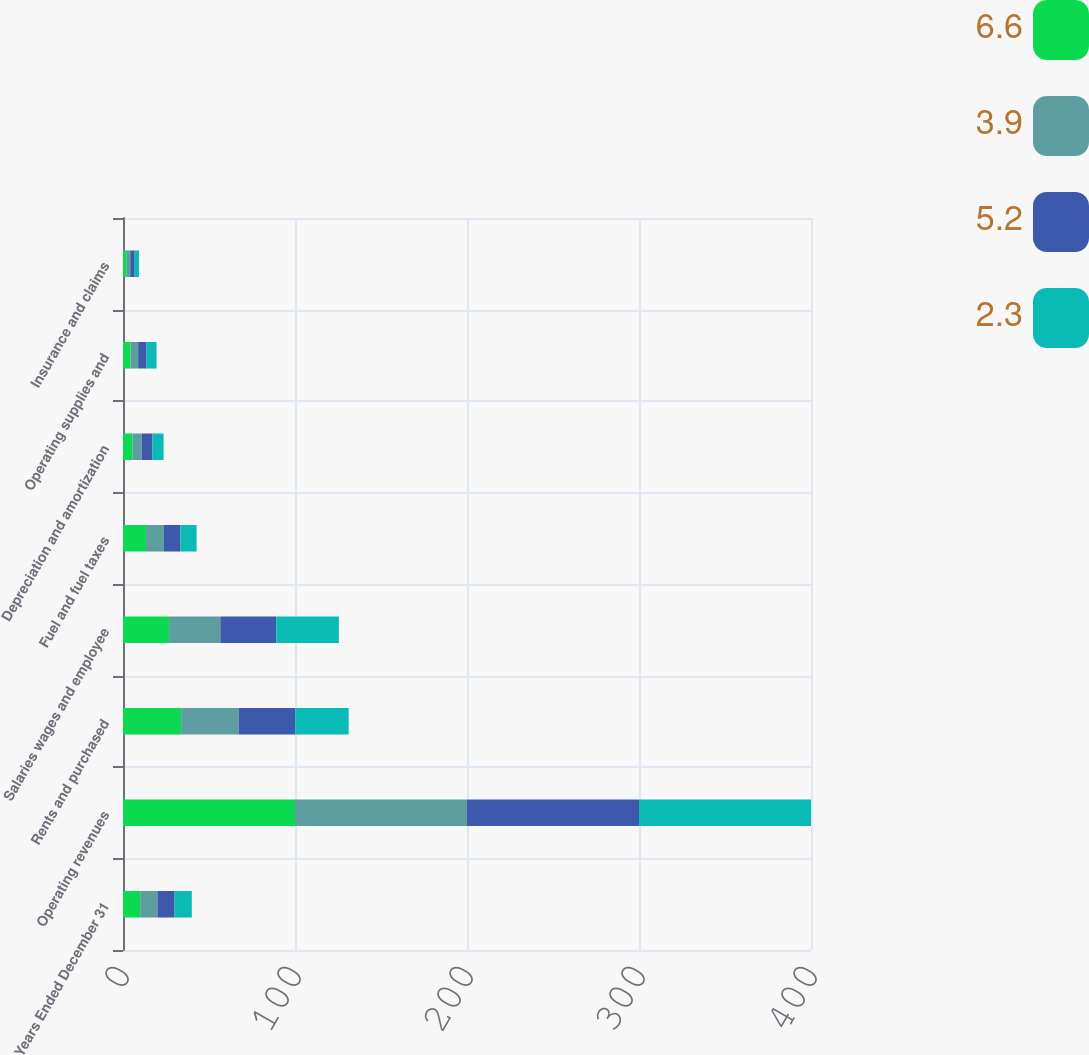Convert chart to OTSL. <chart><loc_0><loc_0><loc_500><loc_500><stacked_bar_chart><ecel><fcel>Years Ended December 31<fcel>Operating revenues<fcel>Rents and purchased<fcel>Salaries wages and employee<fcel>Fuel and fuel taxes<fcel>Depreciation and amortization<fcel>Operating supplies and<fcel>Insurance and claims<nl><fcel>6.6<fcel>10<fcel>100<fcel>33.8<fcel>26.8<fcel>13.4<fcel>5.5<fcel>4.4<fcel>2.2<nl><fcel>3.9<fcel>10<fcel>100<fcel>33.5<fcel>29.8<fcel>10.4<fcel>5.4<fcel>4.4<fcel>2<nl><fcel>5.2<fcel>10<fcel>100<fcel>32.8<fcel>32.5<fcel>9.6<fcel>6.2<fcel>4.9<fcel>2.6<nl><fcel>2.3<fcel>10<fcel>100<fcel>31.1<fcel>36.4<fcel>9.4<fcel>6.5<fcel>5.8<fcel>2.5<nl></chart> 